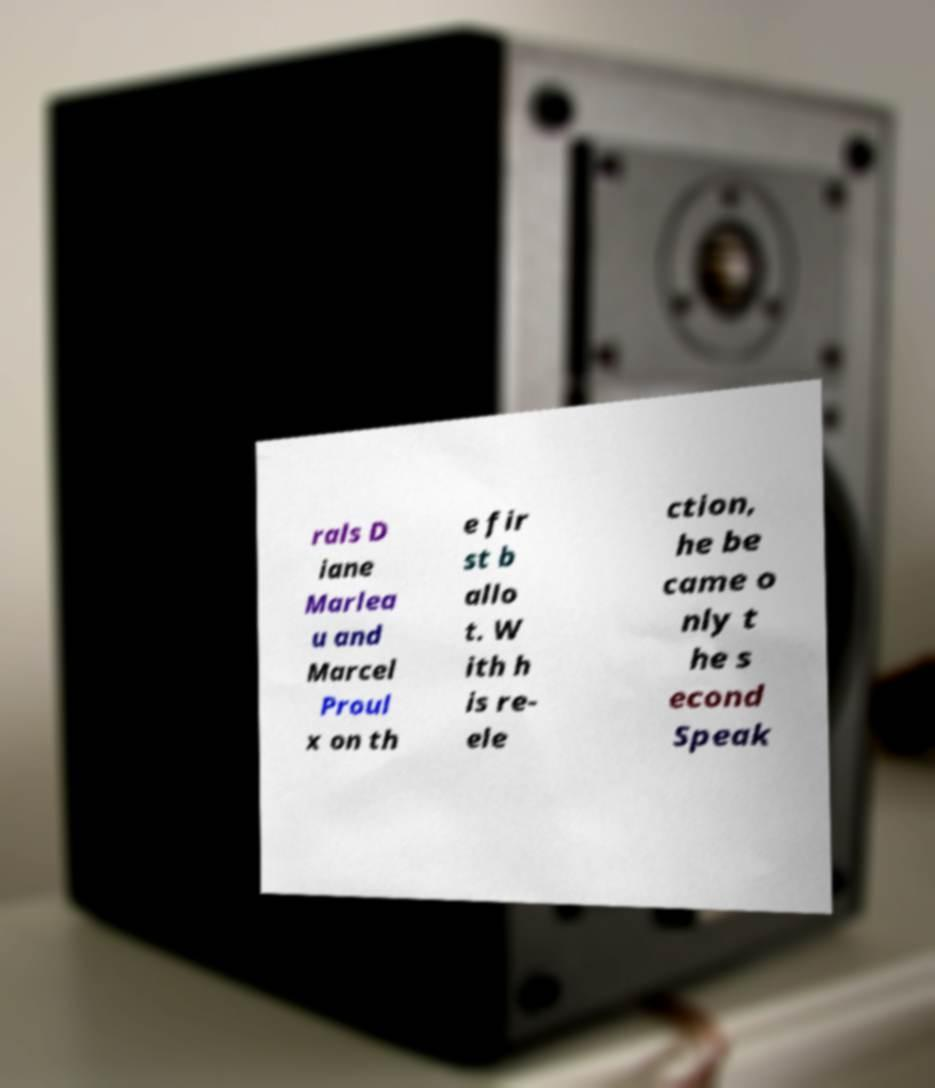There's text embedded in this image that I need extracted. Can you transcribe it verbatim? rals D iane Marlea u and Marcel Proul x on th e fir st b allo t. W ith h is re- ele ction, he be came o nly t he s econd Speak 